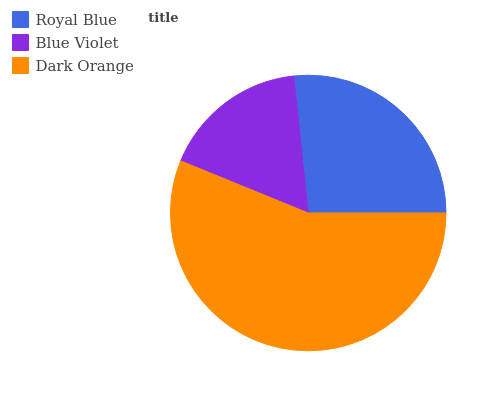Is Blue Violet the minimum?
Answer yes or no. Yes. Is Dark Orange the maximum?
Answer yes or no. Yes. Is Dark Orange the minimum?
Answer yes or no. No. Is Blue Violet the maximum?
Answer yes or no. No. Is Dark Orange greater than Blue Violet?
Answer yes or no. Yes. Is Blue Violet less than Dark Orange?
Answer yes or no. Yes. Is Blue Violet greater than Dark Orange?
Answer yes or no. No. Is Dark Orange less than Blue Violet?
Answer yes or no. No. Is Royal Blue the high median?
Answer yes or no. Yes. Is Royal Blue the low median?
Answer yes or no. Yes. Is Dark Orange the high median?
Answer yes or no. No. Is Blue Violet the low median?
Answer yes or no. No. 